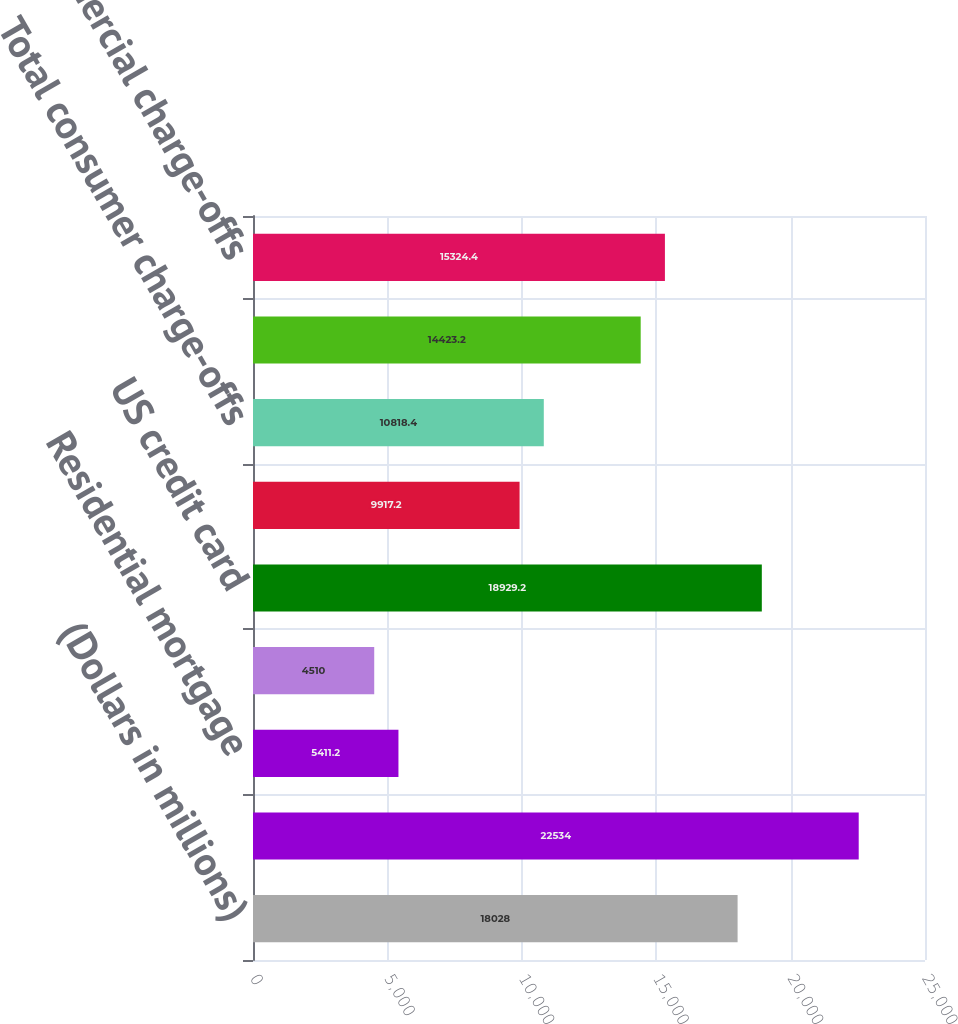<chart> <loc_0><loc_0><loc_500><loc_500><bar_chart><fcel>(Dollars in millions)<fcel>Allowance for loan and lease<fcel>Residential mortgage<fcel>Home equity<fcel>US credit card<fcel>Non-US credit card<fcel>Total consumer charge-offs<fcel>US commercial (1)<fcel>Total commercial charge-offs<nl><fcel>18028<fcel>22534<fcel>5411.2<fcel>4510<fcel>18929.2<fcel>9917.2<fcel>10818.4<fcel>14423.2<fcel>15324.4<nl></chart> 